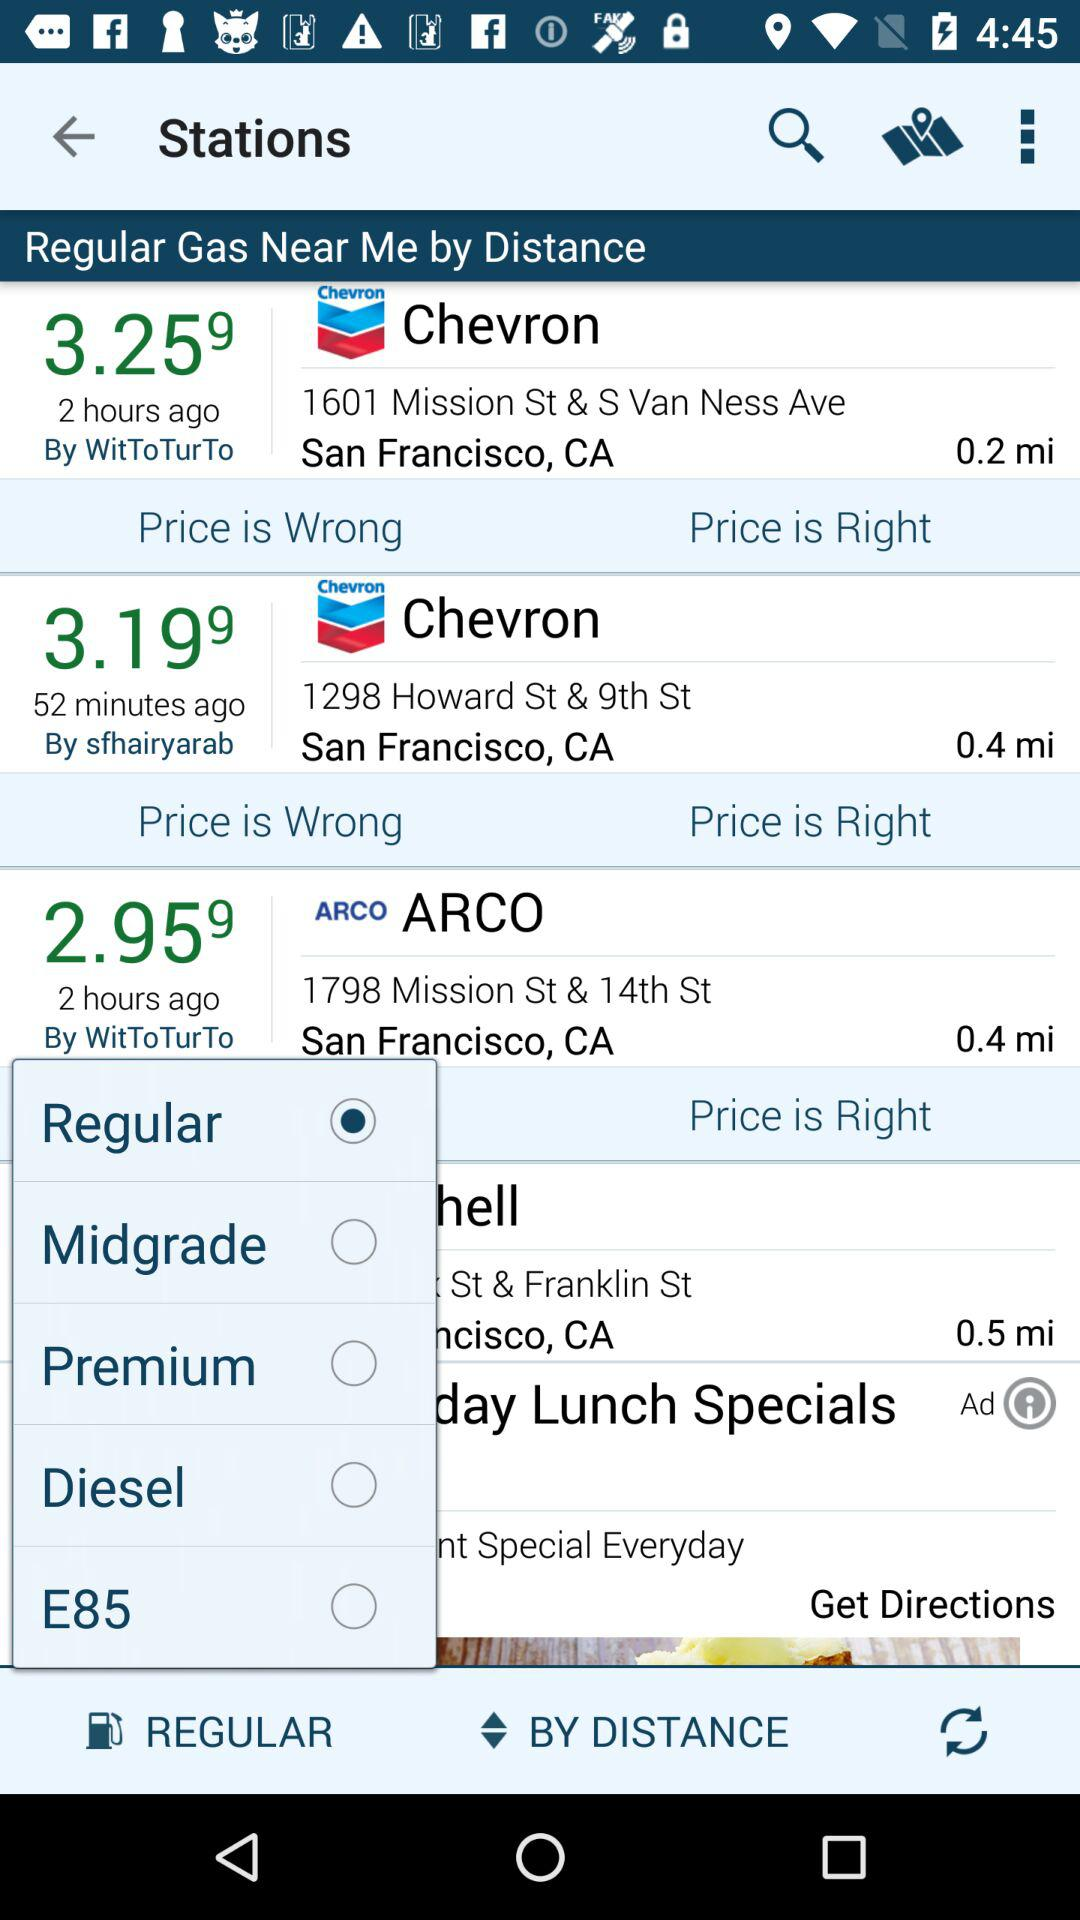What is the distance between the ARCO gas station and my location? The distance between the ARCO gas station and your location is 0.4 miles. 